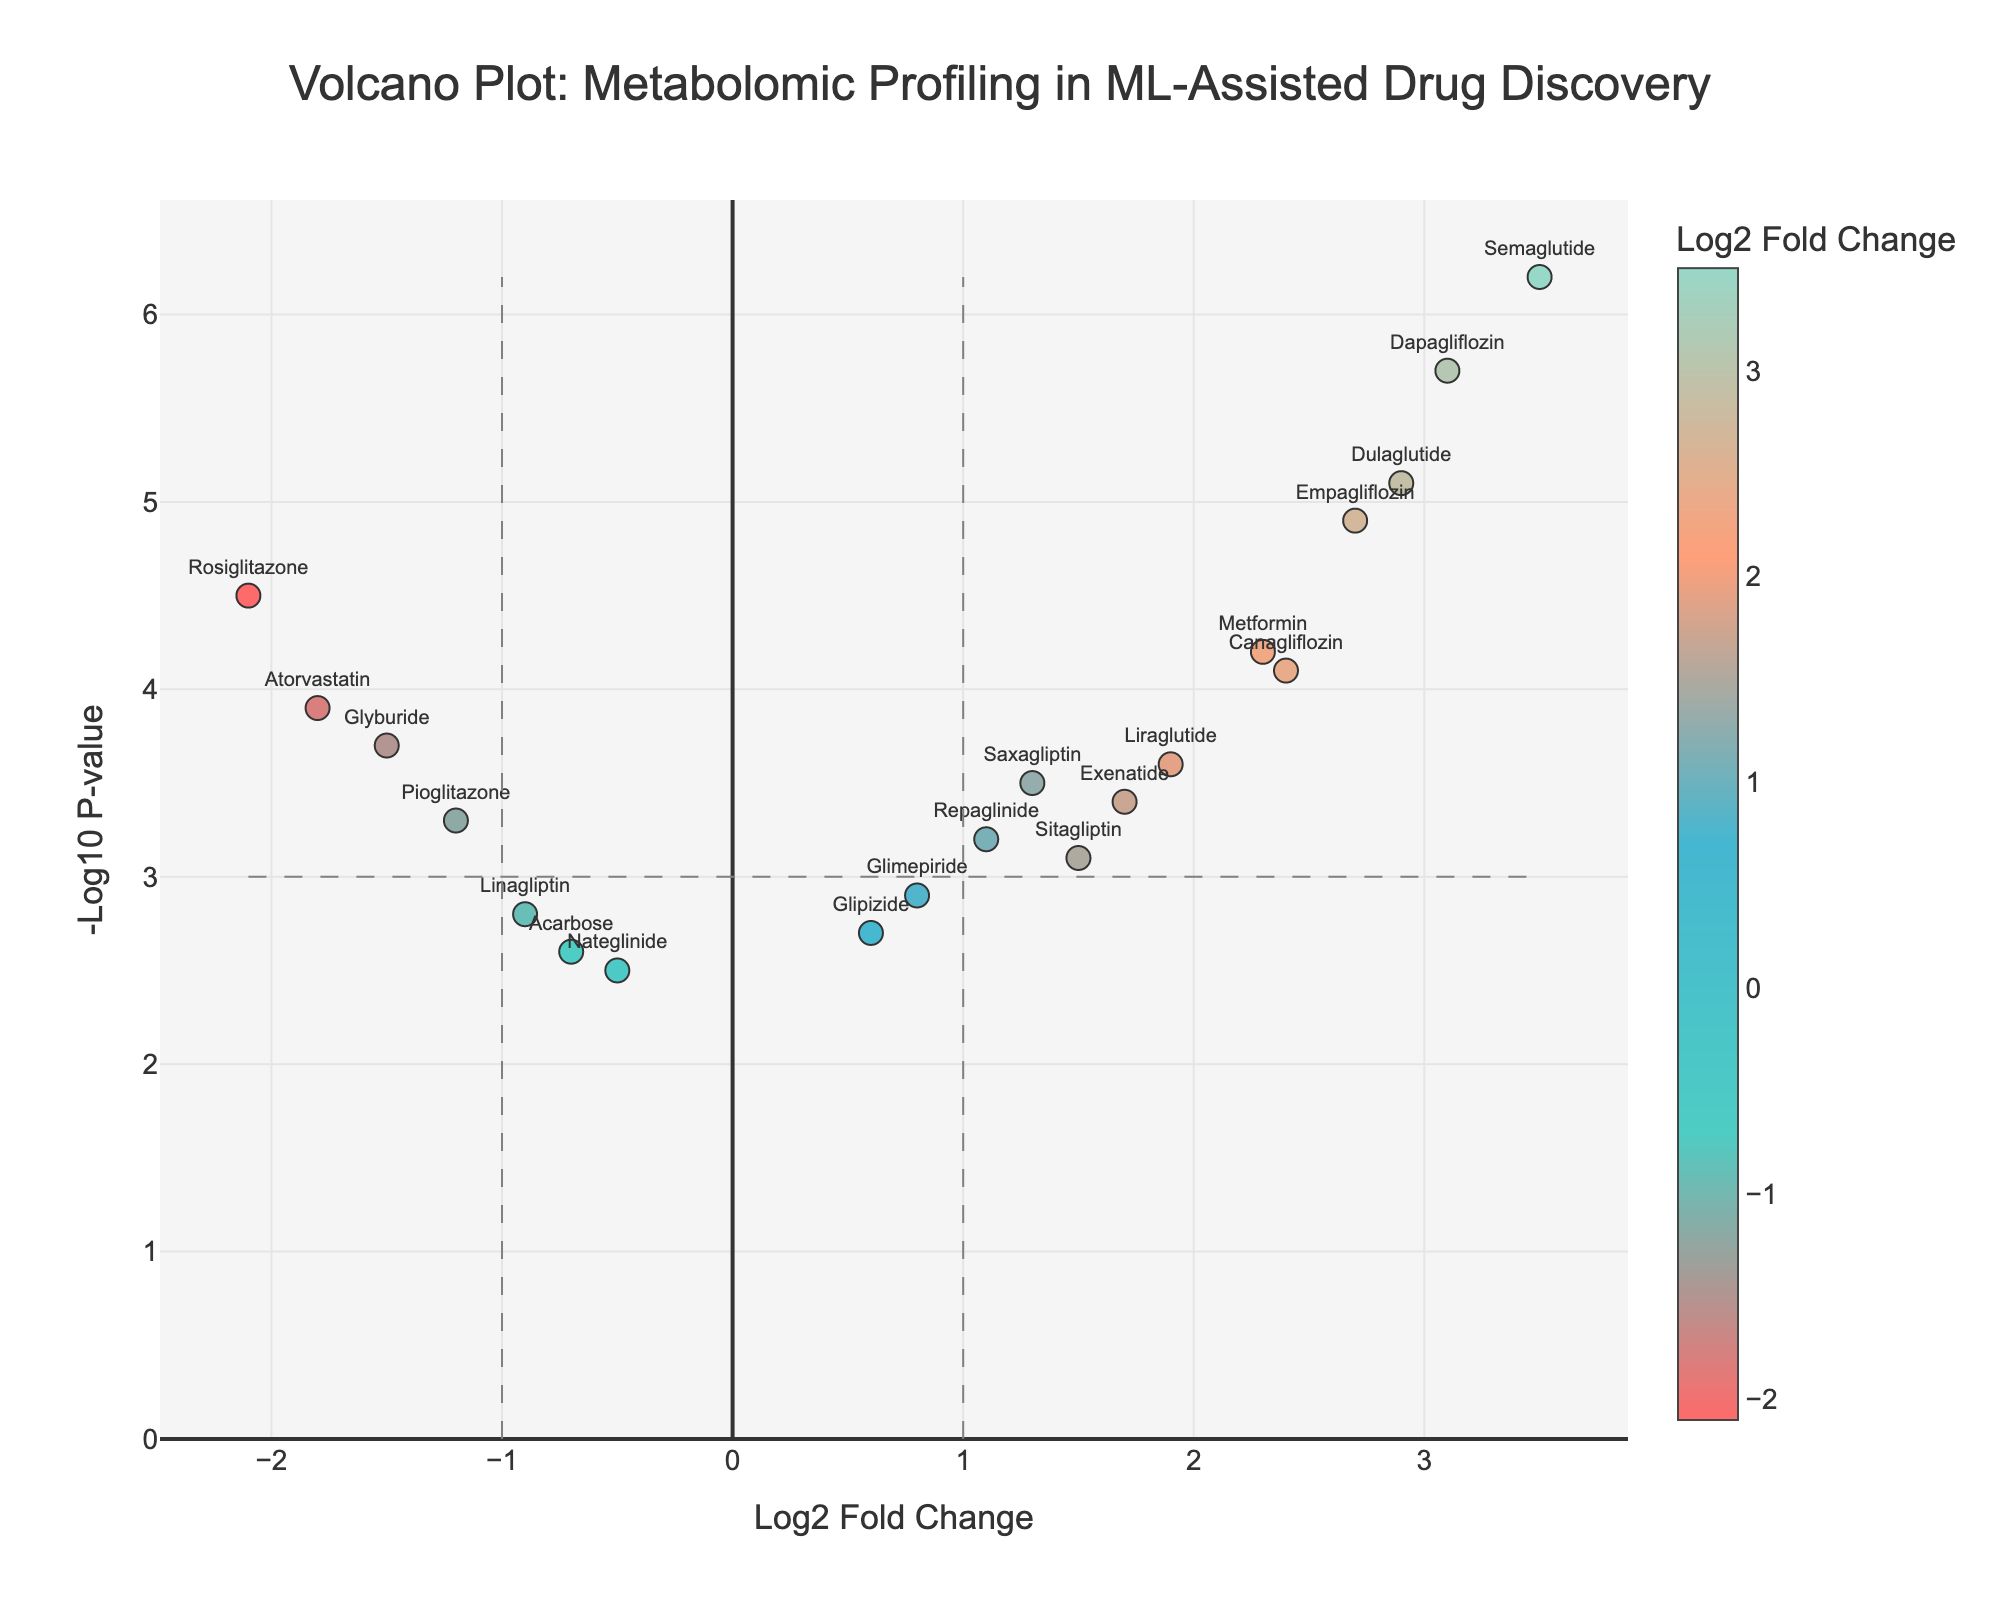How many compounds are highlighted with text labels in the figure? By observing the figure, we can find that every compound is labeled with its name above the marker, such as Metformin, Atorvastatin, Sitagliptin, etc. A quick count of these labels will give us the total number of compounds highlighted.
Answer: 20 Which compound shows the highest -Log10 P-value in the figure? By examining the y-axis values of all points, we identify the point placed the highest, which represents the highest -Log10 P-value. The text label next to this point shows the compound name "Semaglutide".
Answer: Semaglutide Is there any compound with a Log2 Fold Change less than -2? If yes, name it. To identify if any Log2 Fold Change value is less than -2, we look to the left of the y-axis towards values below -2. The point at this level is labeled "Rosiglitazone".
Answer: Rosiglitazone How many compounds have a Log2 Fold Change greater than 2? By assessing all the points on the figure with a Log2 Fold Change above the vertical line at 2, we count the number of such points. Compounds like Metformin, Dapagliflozin, Empagliflozin, Semaglutide, Canagliflozin, and Dulaglutide are identified.
Answer: 6 Which two compounds have the closest -Log10 P-values but opposite Log2 Fold Changes? By comparing the y-axis values of all points, we find that Atorvastatin and Empagliflozin have a nearly identical -Log10 P-value (about 3.9 and 4.9, respectively) but opposite Log2 Fold Changes (-1.8 for Atorvastatin and 2.7 for Empagliflozin).
Answer: Atorvastatin and Empagliflozin What is the Log2 Fold Change and -Log10 P-value for Metformin? The figure shows the Log2 Fold Change on the x-axis and -Log10 P-value on the y-axis. By locating the point labeled "Metformin", we read the corresponding x and y values: 2.3 and 4.2, respectively.
Answer: 2.3, 4.2 Are there more compounds with positive Log2 Fold Changes or negative Log2 Fold Changes? By counting all the points to the right of the y-axis (positive Log2 Fold Changes) and those to the left (negative Log2 Fold Changes), we find more points on the right, indicating more compounds with positive Log2 Fold Changes.
Answer: Positive Log2 Fold Changes Which compound has the smallest -Log10 P-value above the p-value threshold (i.e., -Log10 P-value of 3)? By observing the points just above the horizontal line at -Log10 P-value=3, while ignoring those below, we identify that Saxagliptin has the smallest value just over this threshold.
Answer: Saxagliptin What is the range of the Log2 Fold Change values for the compounds displayed in the figure? By identifying the smallest (Rosiglitazone at -2.1) and the largest (Semaglutide at 3.5) Log2 Fold Change values on the x-axis, the range is computed as the difference between these values.
Answer: 5.6 